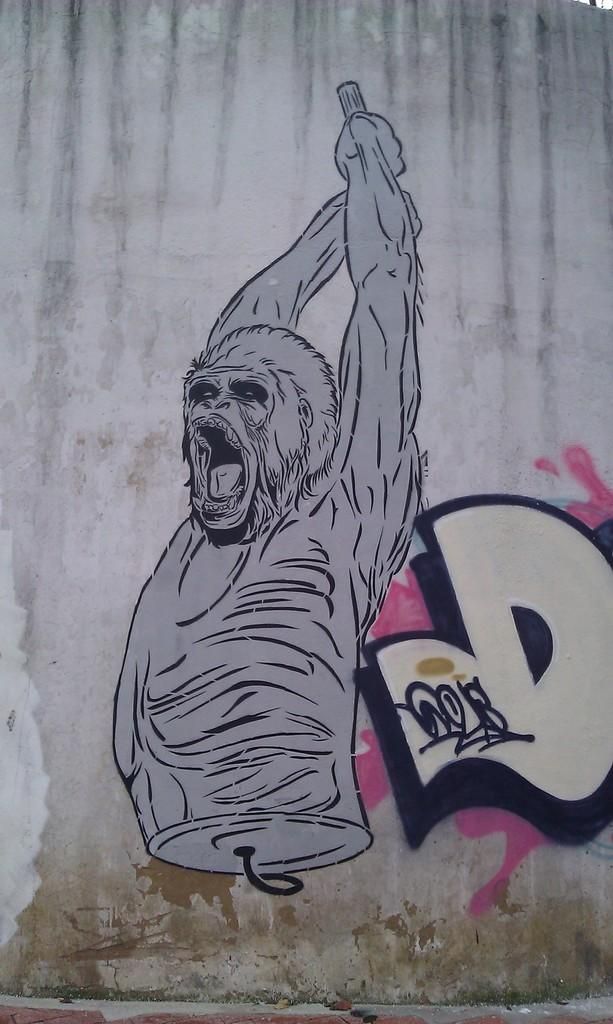What is depicted on the wall in the image? There is a painting of an animal on the wall. What additional information is provided with the painting? There is text associated with the painting. Is there any other object or feature on the painting? Yes, there is a sign on the painting. What type of waste can be seen in the image? There is no waste present in the image; it features a painting of an animal on the wall with text and a sign. What is the reaction of the animal in the painting? The painting is a static image, so there is no reaction of the animal depicted. 